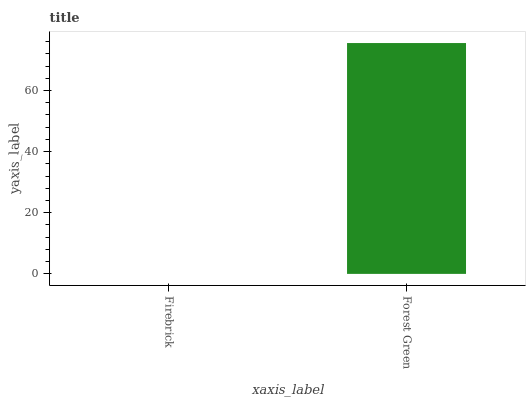Is Firebrick the minimum?
Answer yes or no. Yes. Is Forest Green the maximum?
Answer yes or no. Yes. Is Forest Green the minimum?
Answer yes or no. No. Is Forest Green greater than Firebrick?
Answer yes or no. Yes. Is Firebrick less than Forest Green?
Answer yes or no. Yes. Is Firebrick greater than Forest Green?
Answer yes or no. No. Is Forest Green less than Firebrick?
Answer yes or no. No. Is Forest Green the high median?
Answer yes or no. Yes. Is Firebrick the low median?
Answer yes or no. Yes. Is Firebrick the high median?
Answer yes or no. No. Is Forest Green the low median?
Answer yes or no. No. 